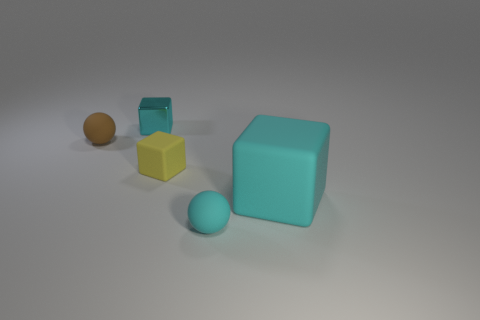How many cyan blocks must be subtracted to get 1 cyan blocks? 1 Subtract all small rubber cubes. How many cubes are left? 2 Subtract all gray cylinders. How many cyan blocks are left? 2 Add 2 big blocks. How many objects exist? 7 Subtract all balls. How many objects are left? 3 Subtract all gray blocks. Subtract all brown balls. How many blocks are left? 3 Subtract all tiny cyan rubber spheres. Subtract all cyan objects. How many objects are left? 1 Add 2 brown matte things. How many brown matte things are left? 3 Add 1 tiny matte spheres. How many tiny matte spheres exist? 3 Subtract 0 purple balls. How many objects are left? 5 